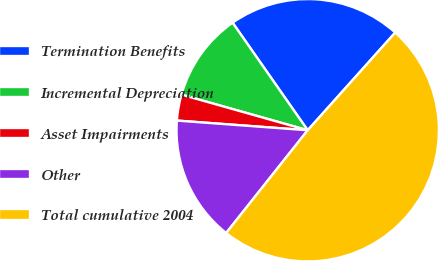<chart> <loc_0><loc_0><loc_500><loc_500><pie_chart><fcel>Termination Benefits<fcel>Incremental Depreciation<fcel>Asset Impairments<fcel>Other<fcel>Total cumulative 2004<nl><fcel>21.33%<fcel>10.92%<fcel>3.2%<fcel>15.5%<fcel>49.05%<nl></chart> 